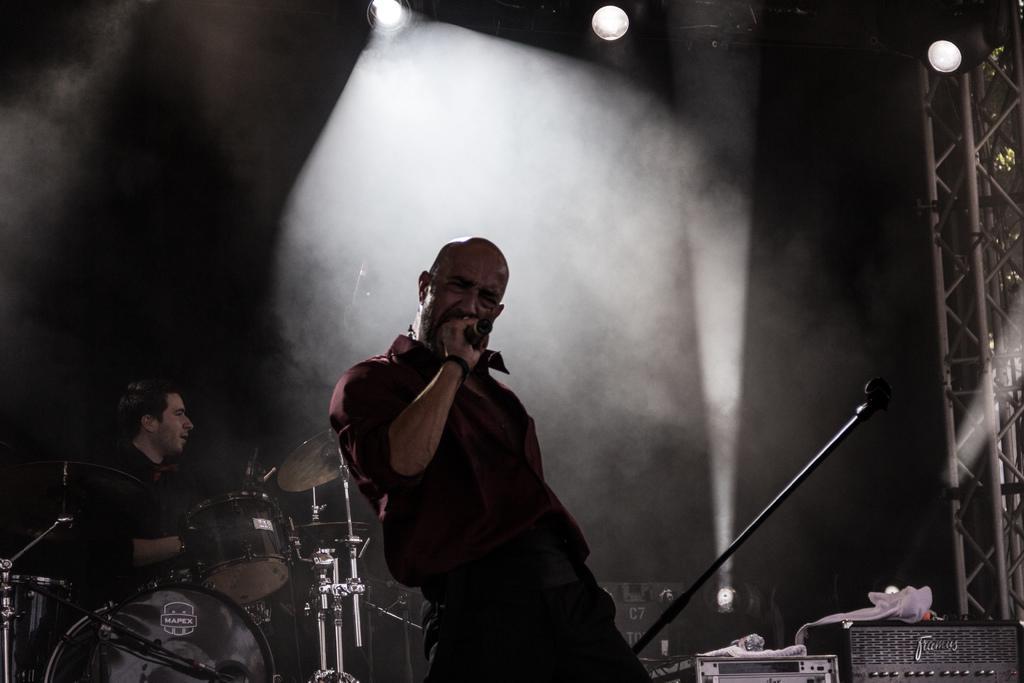Could you give a brief overview of what you see in this image? In this picture we can see a person holding a microphone and standing. There are drums and other musical instruments. We can see a person sitting. There are electronic devices, lights and other objects. 